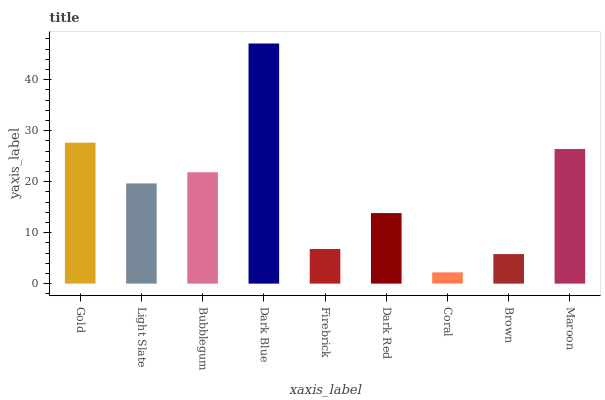Is Coral the minimum?
Answer yes or no. Yes. Is Dark Blue the maximum?
Answer yes or no. Yes. Is Light Slate the minimum?
Answer yes or no. No. Is Light Slate the maximum?
Answer yes or no. No. Is Gold greater than Light Slate?
Answer yes or no. Yes. Is Light Slate less than Gold?
Answer yes or no. Yes. Is Light Slate greater than Gold?
Answer yes or no. No. Is Gold less than Light Slate?
Answer yes or no. No. Is Light Slate the high median?
Answer yes or no. Yes. Is Light Slate the low median?
Answer yes or no. Yes. Is Dark Red the high median?
Answer yes or no. No. Is Firebrick the low median?
Answer yes or no. No. 